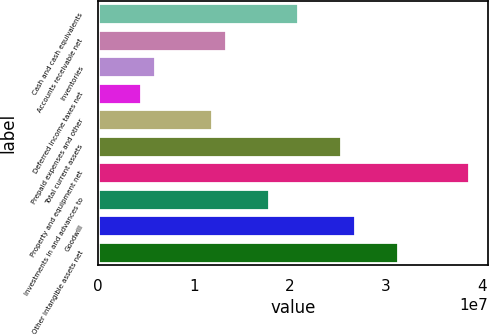Convert chart to OTSL. <chart><loc_0><loc_0><loc_500><loc_500><bar_chart><fcel>Cash and cash equivalents<fcel>Accounts receivable net<fcel>Inventories<fcel>Deferred income taxes net<fcel>Prepaid expenses and other<fcel>Total current assets<fcel>Property and equipment net<fcel>Investments in and advances to<fcel>Goodwill<fcel>Other intangible assets net<nl><fcel>2.08113e+07<fcel>1.33805e+07<fcel>5.94959e+06<fcel>4.46341e+06<fcel>1.18943e+07<fcel>2.52699e+07<fcel>3.86455e+07<fcel>1.7839e+07<fcel>2.6756e+07<fcel>3.12146e+07<nl></chart> 